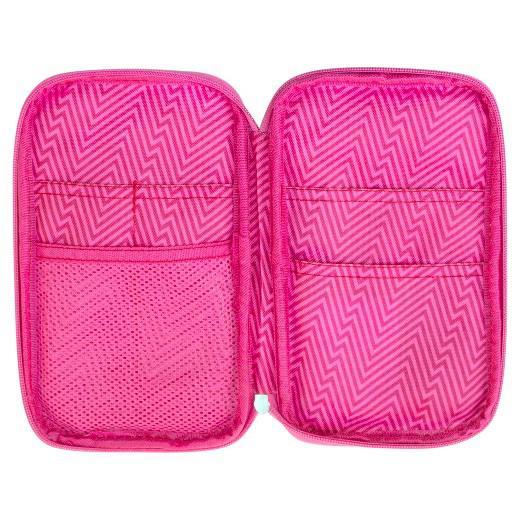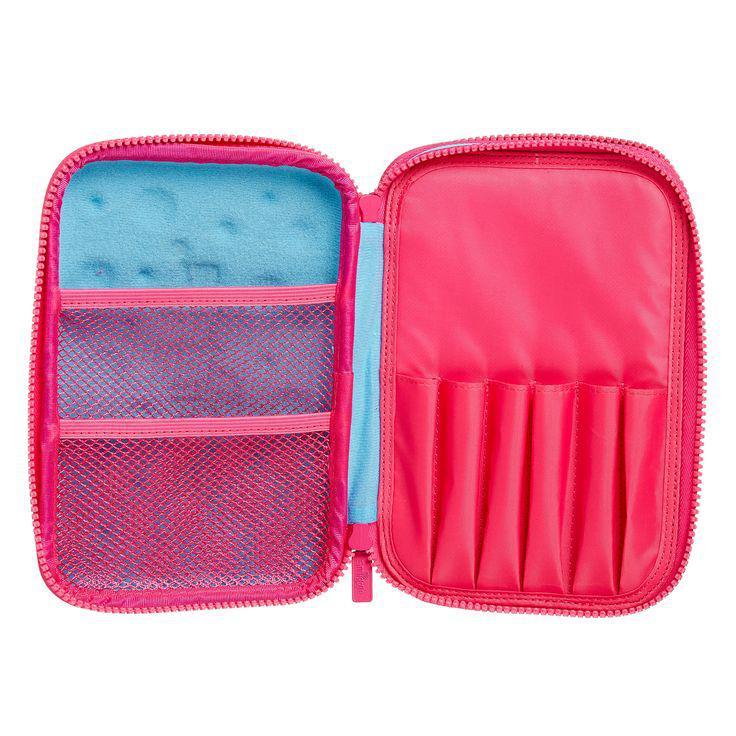The first image is the image on the left, the second image is the image on the right. Evaluate the accuracy of this statement regarding the images: "One of the images shows a pink pencil case opened to reveal a blue lining on one side.". Is it true? Answer yes or no. Yes. The first image is the image on the left, the second image is the image on the right. Evaluate the accuracy of this statement regarding the images: "Each image shows one zipper pencil case with rounded corners, and the cases in the left and right images are shown in the same position and configuration.". Is it true? Answer yes or no. Yes. 